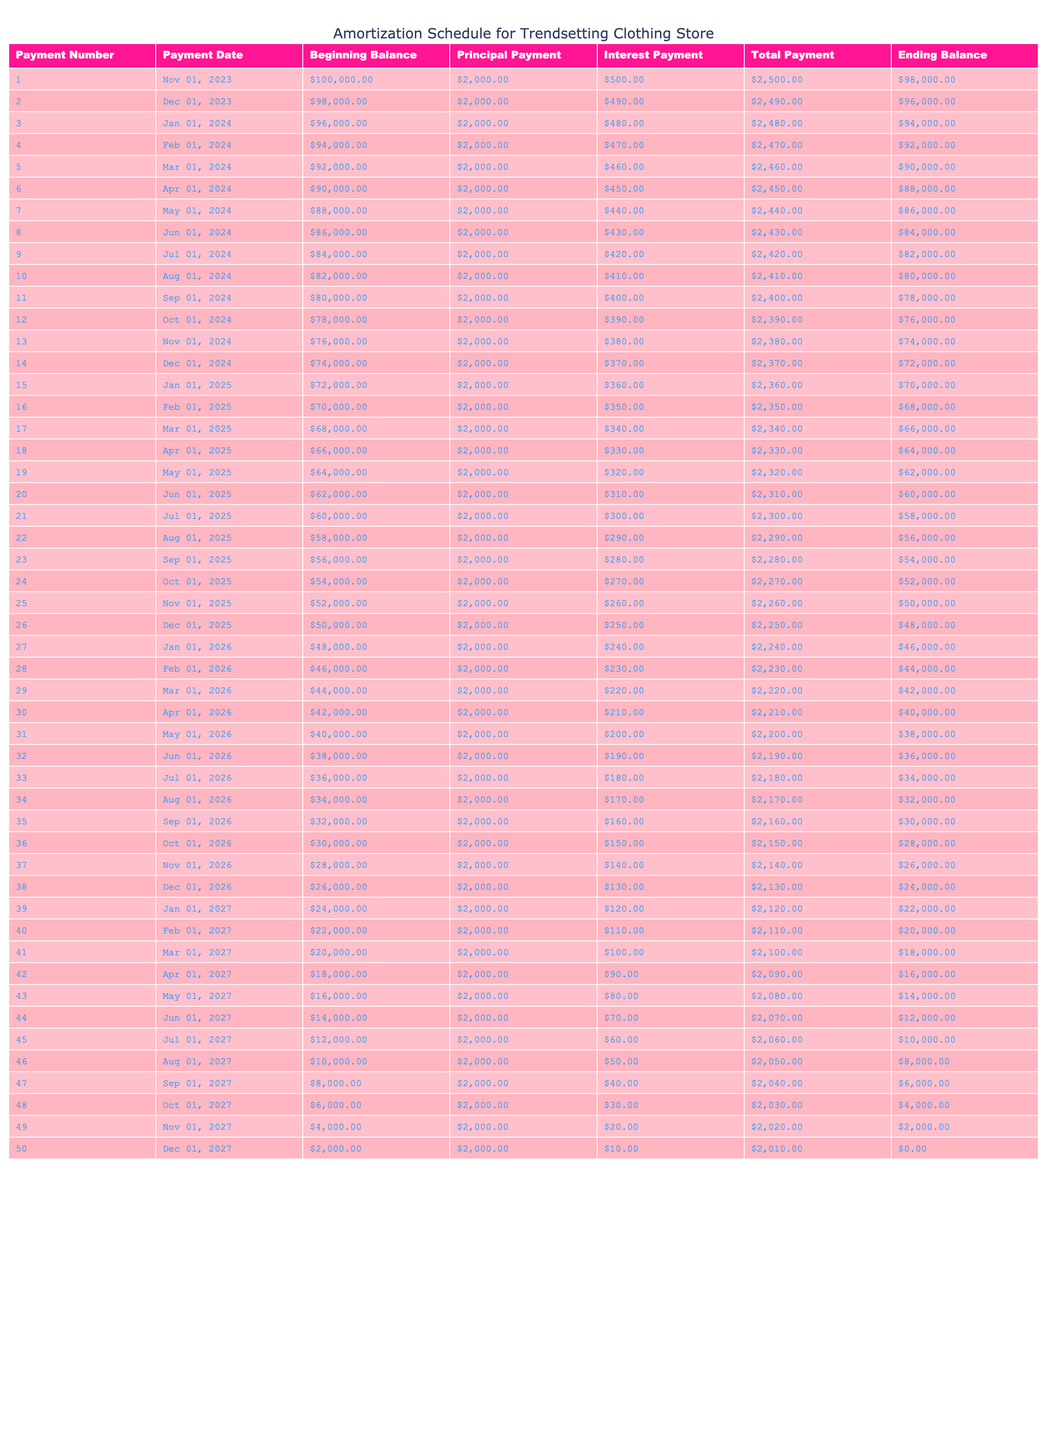What is the total payment made in the first month? In the first month, the Total Payment is listed as $2,500.
Answer: $2,500 What is the Ending Balance after the 12th payment? Referring to the table, the Ending Balance after the 12th payment is $76,000.
Answer: $76,000 How much is the total principal paid after the first six months? The Principal Payments for the first six months are $2,000 each month, totaling $2,000 * 6 = $12,000.
Answer: $12,000 Is the Interest Payment less than $500 in the 24th month? In the 24th month, the Interest Payment is $270, which is less than $500.
Answer: Yes What is the average Total Payment made over the first five payments? The Total Payments for the first five months are $2,500, $2,490, $2,480, $2,470, and $2,460, summing to $12,400. Dividing by five gives an average of $12,400 / 5 = $2,480.
Answer: $2,480 After the 30th payment, what is the remaining balance? The Ending Balance after the 30th payment is $40,000, as indicated in the table.
Answer: $40,000 How much more interest is paid in the second payment compared to the first payment? The Interest Payment for the first month is $500, and for the second month, it is $490. The difference is $500 - $490 = $10.
Answer: $10 What is the total amount of interest paid after the first year? The Interest Payments for the first 12 months sum up as follows: $500, $490, $480, $470, $460, $450, $440, $430, $420, $410, $400, and $390, totaling $5,820.
Answer: $5,820 What is the percentage of the total amount paid that goes towards principal over the first 24 payments? The total Principal Payments over the first 24 months are $48,000 ($2,000 every month). The total paid during this period is $59,280 ($2,470 average payment over 24 months). The percentage for principal is $48,000 / $59,280 * 100 ≈ 80.92%.
Answer: 80.92% 